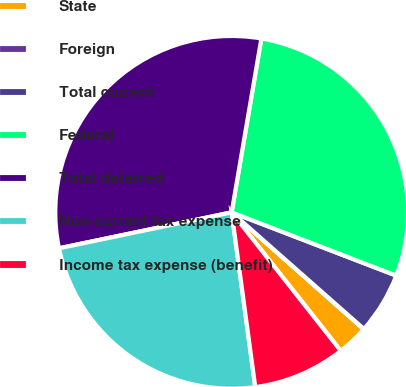Convert chart. <chart><loc_0><loc_0><loc_500><loc_500><pie_chart><fcel>State<fcel>Foreign<fcel>Total current<fcel>Federal<fcel>Total deferred<fcel>Non-current tax expense<fcel>Income tax expense (benefit)<nl><fcel>2.85%<fcel>0.03%<fcel>5.66%<fcel>28.14%<fcel>30.96%<fcel>23.87%<fcel>8.48%<nl></chart> 